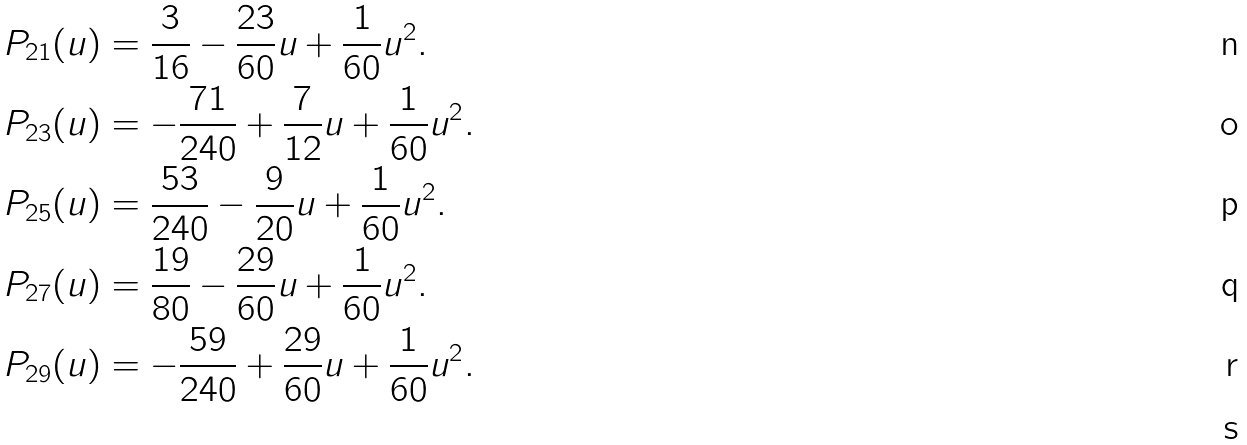Convert formula to latex. <formula><loc_0><loc_0><loc_500><loc_500>P _ { 2 1 } ( u ) & = \frac { 3 } { 1 6 } - \frac { 2 3 } { 6 0 } u + \frac { 1 } { 6 0 } u ^ { 2 } . \\ P _ { 2 3 } ( u ) & = - \frac { 7 1 } { 2 4 0 } + \frac { 7 } { 1 2 } u + \frac { 1 } { 6 0 } u ^ { 2 } . \\ P _ { 2 5 } ( u ) & = \frac { 5 3 } { 2 4 0 } - \frac { 9 } { 2 0 } u + \frac { 1 } { 6 0 } u ^ { 2 } . \\ P _ { 2 7 } ( u ) & = \frac { 1 9 } { 8 0 } - \frac { 2 9 } { 6 0 } u + \frac { 1 } { 6 0 } u ^ { 2 } . \\ P _ { 2 9 } ( u ) & = - \frac { 5 9 } { 2 4 0 } + \frac { 2 9 } { 6 0 } u + \frac { 1 } { 6 0 } u ^ { 2 } . \\</formula> 